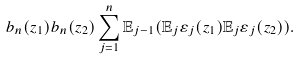<formula> <loc_0><loc_0><loc_500><loc_500>b _ { n } ( z _ { 1 } ) b _ { n } ( z _ { 2 } ) \sum _ { j = 1 } ^ { n } \mathbb { E } _ { j - 1 } ( \mathbb { E } _ { j } \varepsilon _ { j } ( z _ { 1 } ) \mathbb { E } _ { j } \varepsilon _ { j } ( z _ { 2 } ) ) .</formula> 